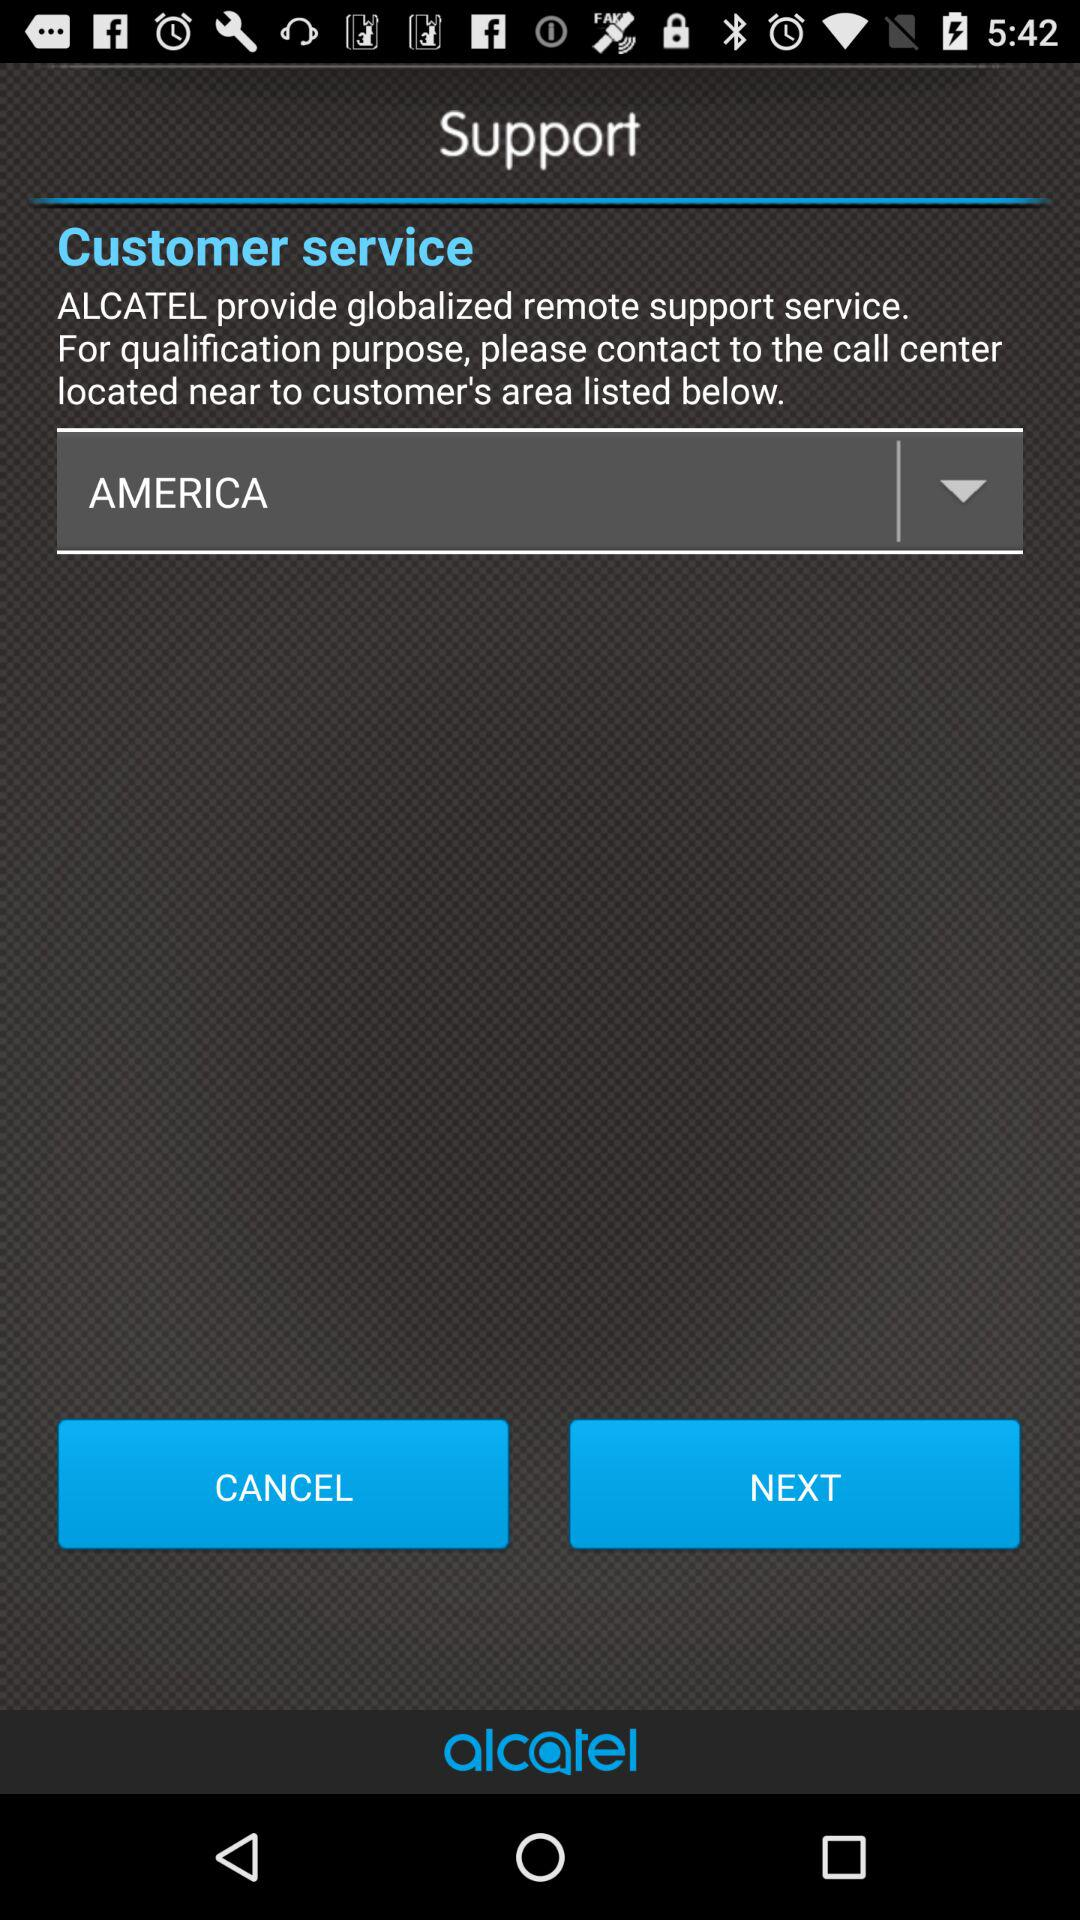Which country is selected? The selected country is America. 